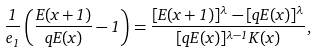Convert formula to latex. <formula><loc_0><loc_0><loc_500><loc_500>\frac { 1 } { e _ { 1 } } \left ( \frac { E ( x + 1 ) } { q E ( x ) } - 1 \right ) = \frac { [ E ( x + 1 ) ] ^ { \lambda } - [ q E ( x ) ] ^ { \lambda } } { [ q E ( x ) ] ^ { \lambda - 1 } K ( x ) } ,</formula> 